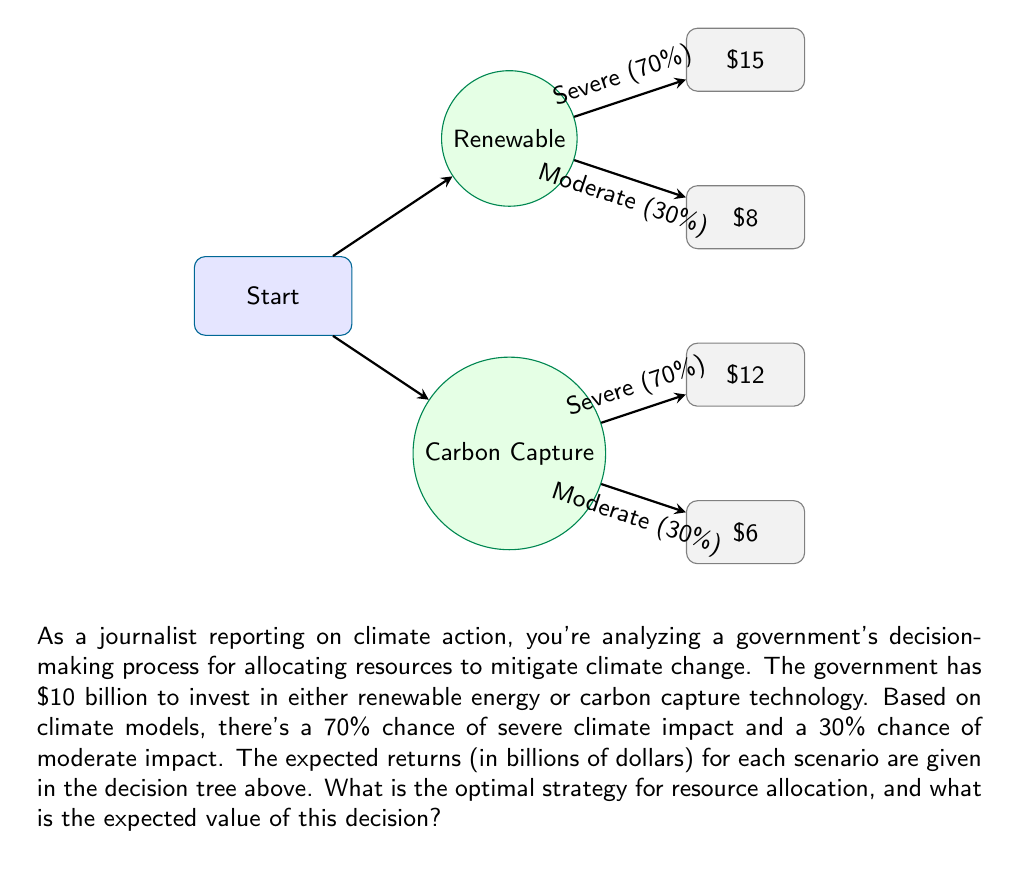Could you help me with this problem? To solve this problem, we'll use the concept of expected value in decision trees. Let's break it down step-by-step:

1. Calculate the expected value for the Renewable Energy option:
   $$EV(Renewable) = 0.70 \times 15 + 0.30 \times 8 = 10.5 + 2.4 = 12.9$$

2. Calculate the expected value for the Carbon Capture option:
   $$EV(Carbon Capture) = 0.70 \times 12 + 0.30 \times 6 = 8.4 + 1.8 = 10.2$$

3. Compare the expected values:
   The expected value of investing in Renewable Energy ($12.9 billion) is higher than the expected value of investing in Carbon Capture ($10.2 billion).

4. Determine the optimal strategy:
   Based on the expected values, the optimal strategy is to invest the $10 billion in Renewable Energy.

5. Calculate the expected value of the decision:
   Since the optimal strategy is to invest in Renewable Energy, the expected value of this decision is $12.9 billion.

This analysis shows that, given the climate model predictions and potential returns, investing in renewable energy is expected to yield better results for climate change mitigation. As a journalist, this information can be used to highlight the importance of data-driven decision-making in climate action and the potential benefits of prioritizing renewable energy investments.
Answer: The optimal strategy is to invest $10 billion in Renewable Energy, with an expected value of $12.9 billion. 